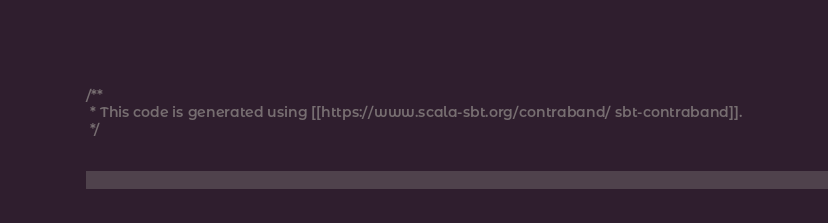Convert code to text. <code><loc_0><loc_0><loc_500><loc_500><_Scala_>/**
 * This code is generated using [[https://www.scala-sbt.org/contraband/ sbt-contraband]].
 */
</code> 